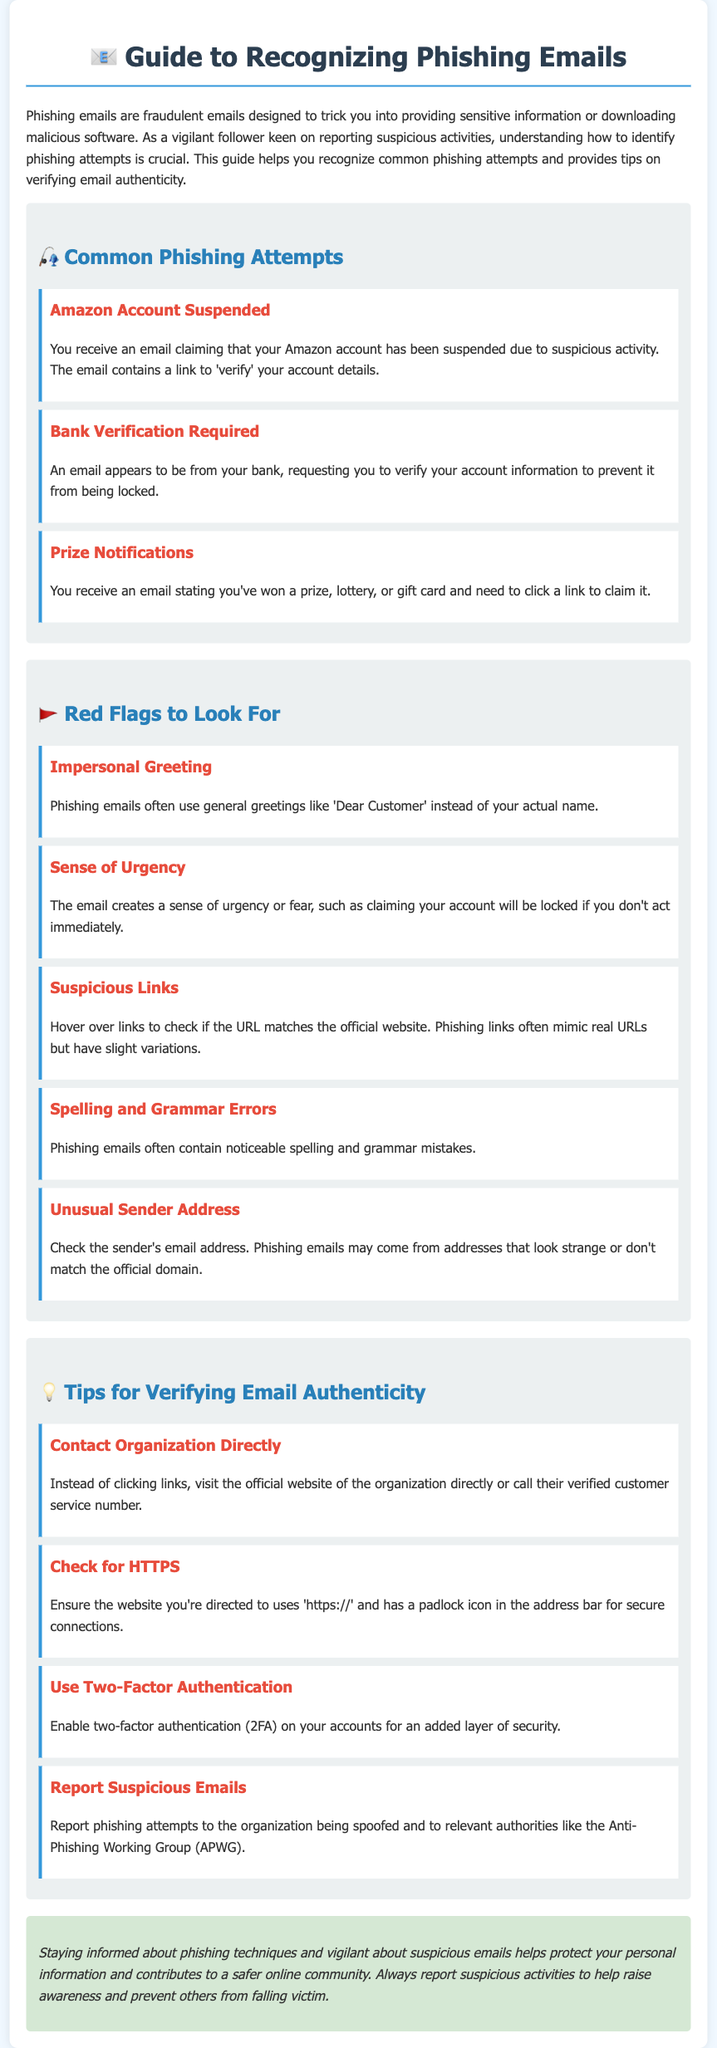What is the title of the guide? The title is stated prominently at the top of the document, indicating the main focus of the content.
Answer: Guide to Recognizing Phishing Emails What is a common phishing attempt example related to Amazon? The document provides specific examples, which include the email about Amazon account issues as a phishing attempt.
Answer: Amazon Account Suspended What should you do if you receive a suspicious email? The guide lists several actions to take, emphasizing the importance of reporting and verifying.
Answer: Report Suspicious Emails What is one red flag indicating a phishing email? The guide identifies several red flags, among them is the use of impersonal greetings, which is a common tactic in phishing.
Answer: Impersonal Greeting What is the recommended method to verify email authenticity? The guide suggests a few best practices for verification, highlighting one effective method.
Answer: Contact Organization Directly Which security feature can enhance account safety? The document outlines a specific security measure that can be implemented for additional protection against phishing attacks.
Answer: Two-Factor Authentication How should suspected phishing attempts be reported? The document mentions the relevant authorities and organizations to contact for reporting.
Answer: Anti-Phishing Working Group (APWG) What is the color of the container background in the document? The design choices in the document specify the background color of the main container used to display the content.
Answer: White How many common phishing attempts are listed in the document? The guide enumerates a set number of phishing attempt examples, providing clear information on common scams.
Answer: Three 